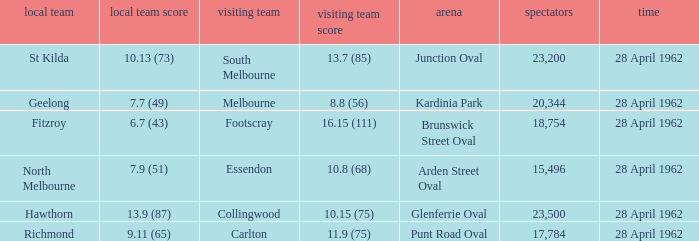At what venue did an away team score 10.15 (75)? Glenferrie Oval. 